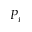<formula> <loc_0><loc_0><loc_500><loc_500>P _ { i }</formula> 